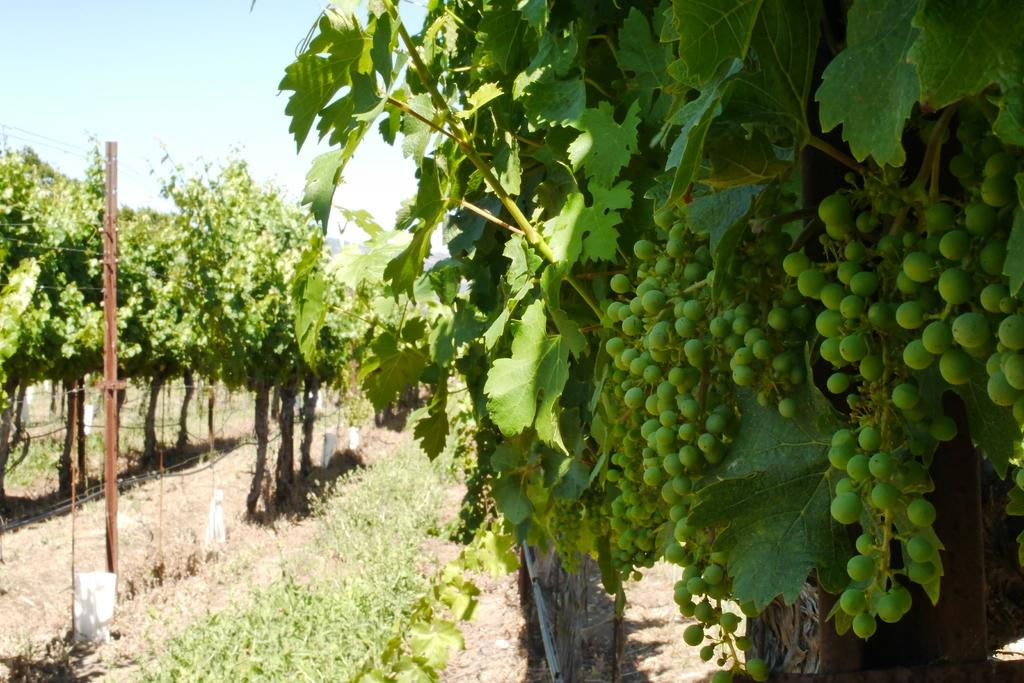What type of fruit can be seen on the plants in the image? There are bunches of grapes on plants in the image. What structures are present in the image? There are poles in the image. What other types of plants can be seen in the image? There are other plants in the image. What is the ground covered with in the image? The ground is covered with grass in the image. What can be seen in the background of the image? The sky is visible in the background of the image. How does the earthquake affect the grape plants in the image? There is no earthquake present in the image, so its effects cannot be observed. 